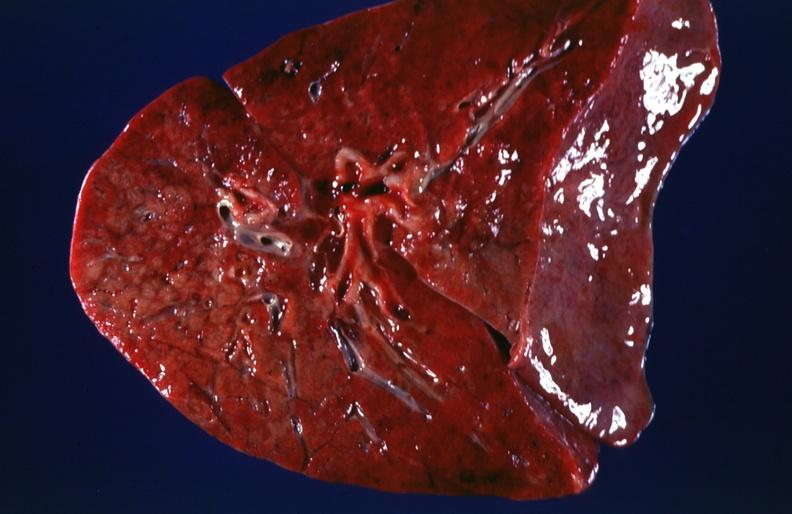does whipples disease show lung, cystic fibrosis?
Answer the question using a single word or phrase. No 